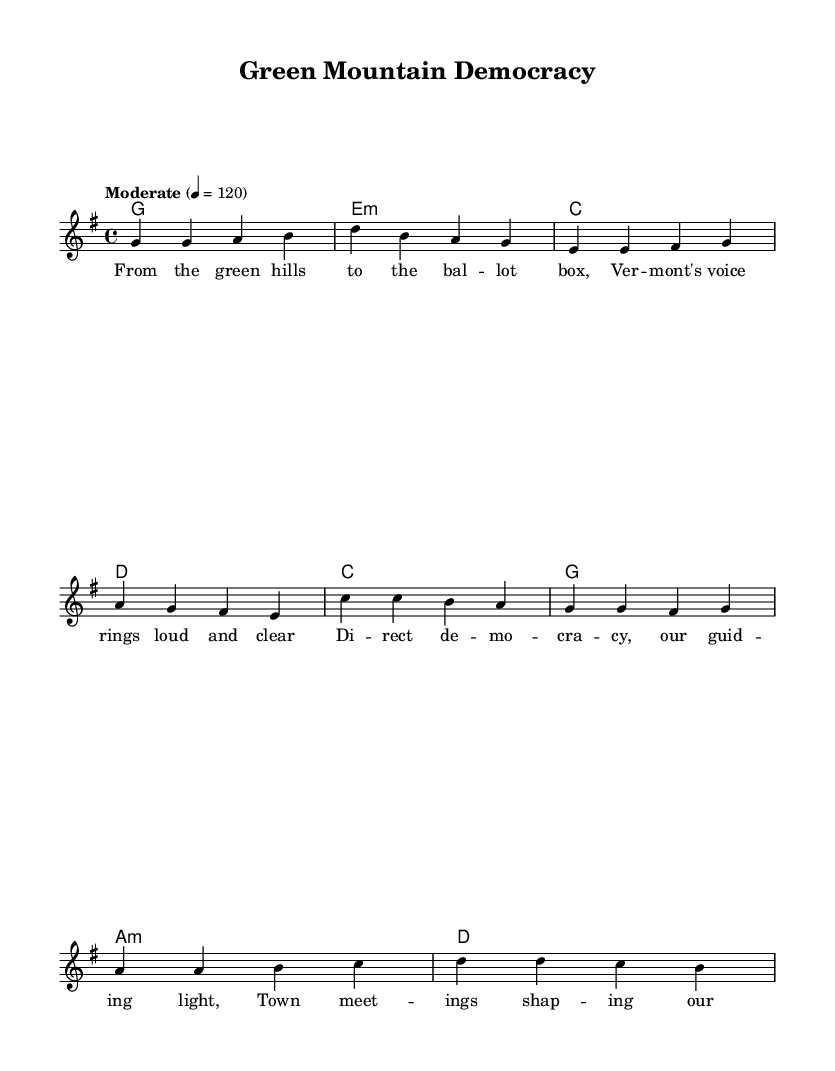What is the key signature of this music? The key signature is G major, which contains one sharp (F#). This can be identified by looking at the key signature section at the beginning of the staff.
Answer: G major What is the time signature of the piece? The time signature is 4/4, as indicated at the beginning of the score, showing that there are four beats in each measure.
Answer: 4/4 What is the tempo marking? The tempo marking is "Moderate" with a tempo of 120 beats per minute, providing a guideline on the intended speed of the piece.
Answer: Moderate How many measures are in the verse section? The verse section consists of four measures as shown in the melody line, counting directly from the notation.
Answer: 4 Which harmony is used in the chorus? The harmony used in the chorus is C major, which is the chord indicated for the first measure of the chorus section.
Answer: C What is the last lyric in the chorus? The last lyric in the chorus is "bright" as seen at the end of the lyrical section corresponding to the chorus in the score.
Answer: bright What is the overall theme of the lyrics? The overall theme of the lyrics revolves around democracy and community involvement, as they speak to Vermont's political traditions and citizen engagement.
Answer: Democracy 